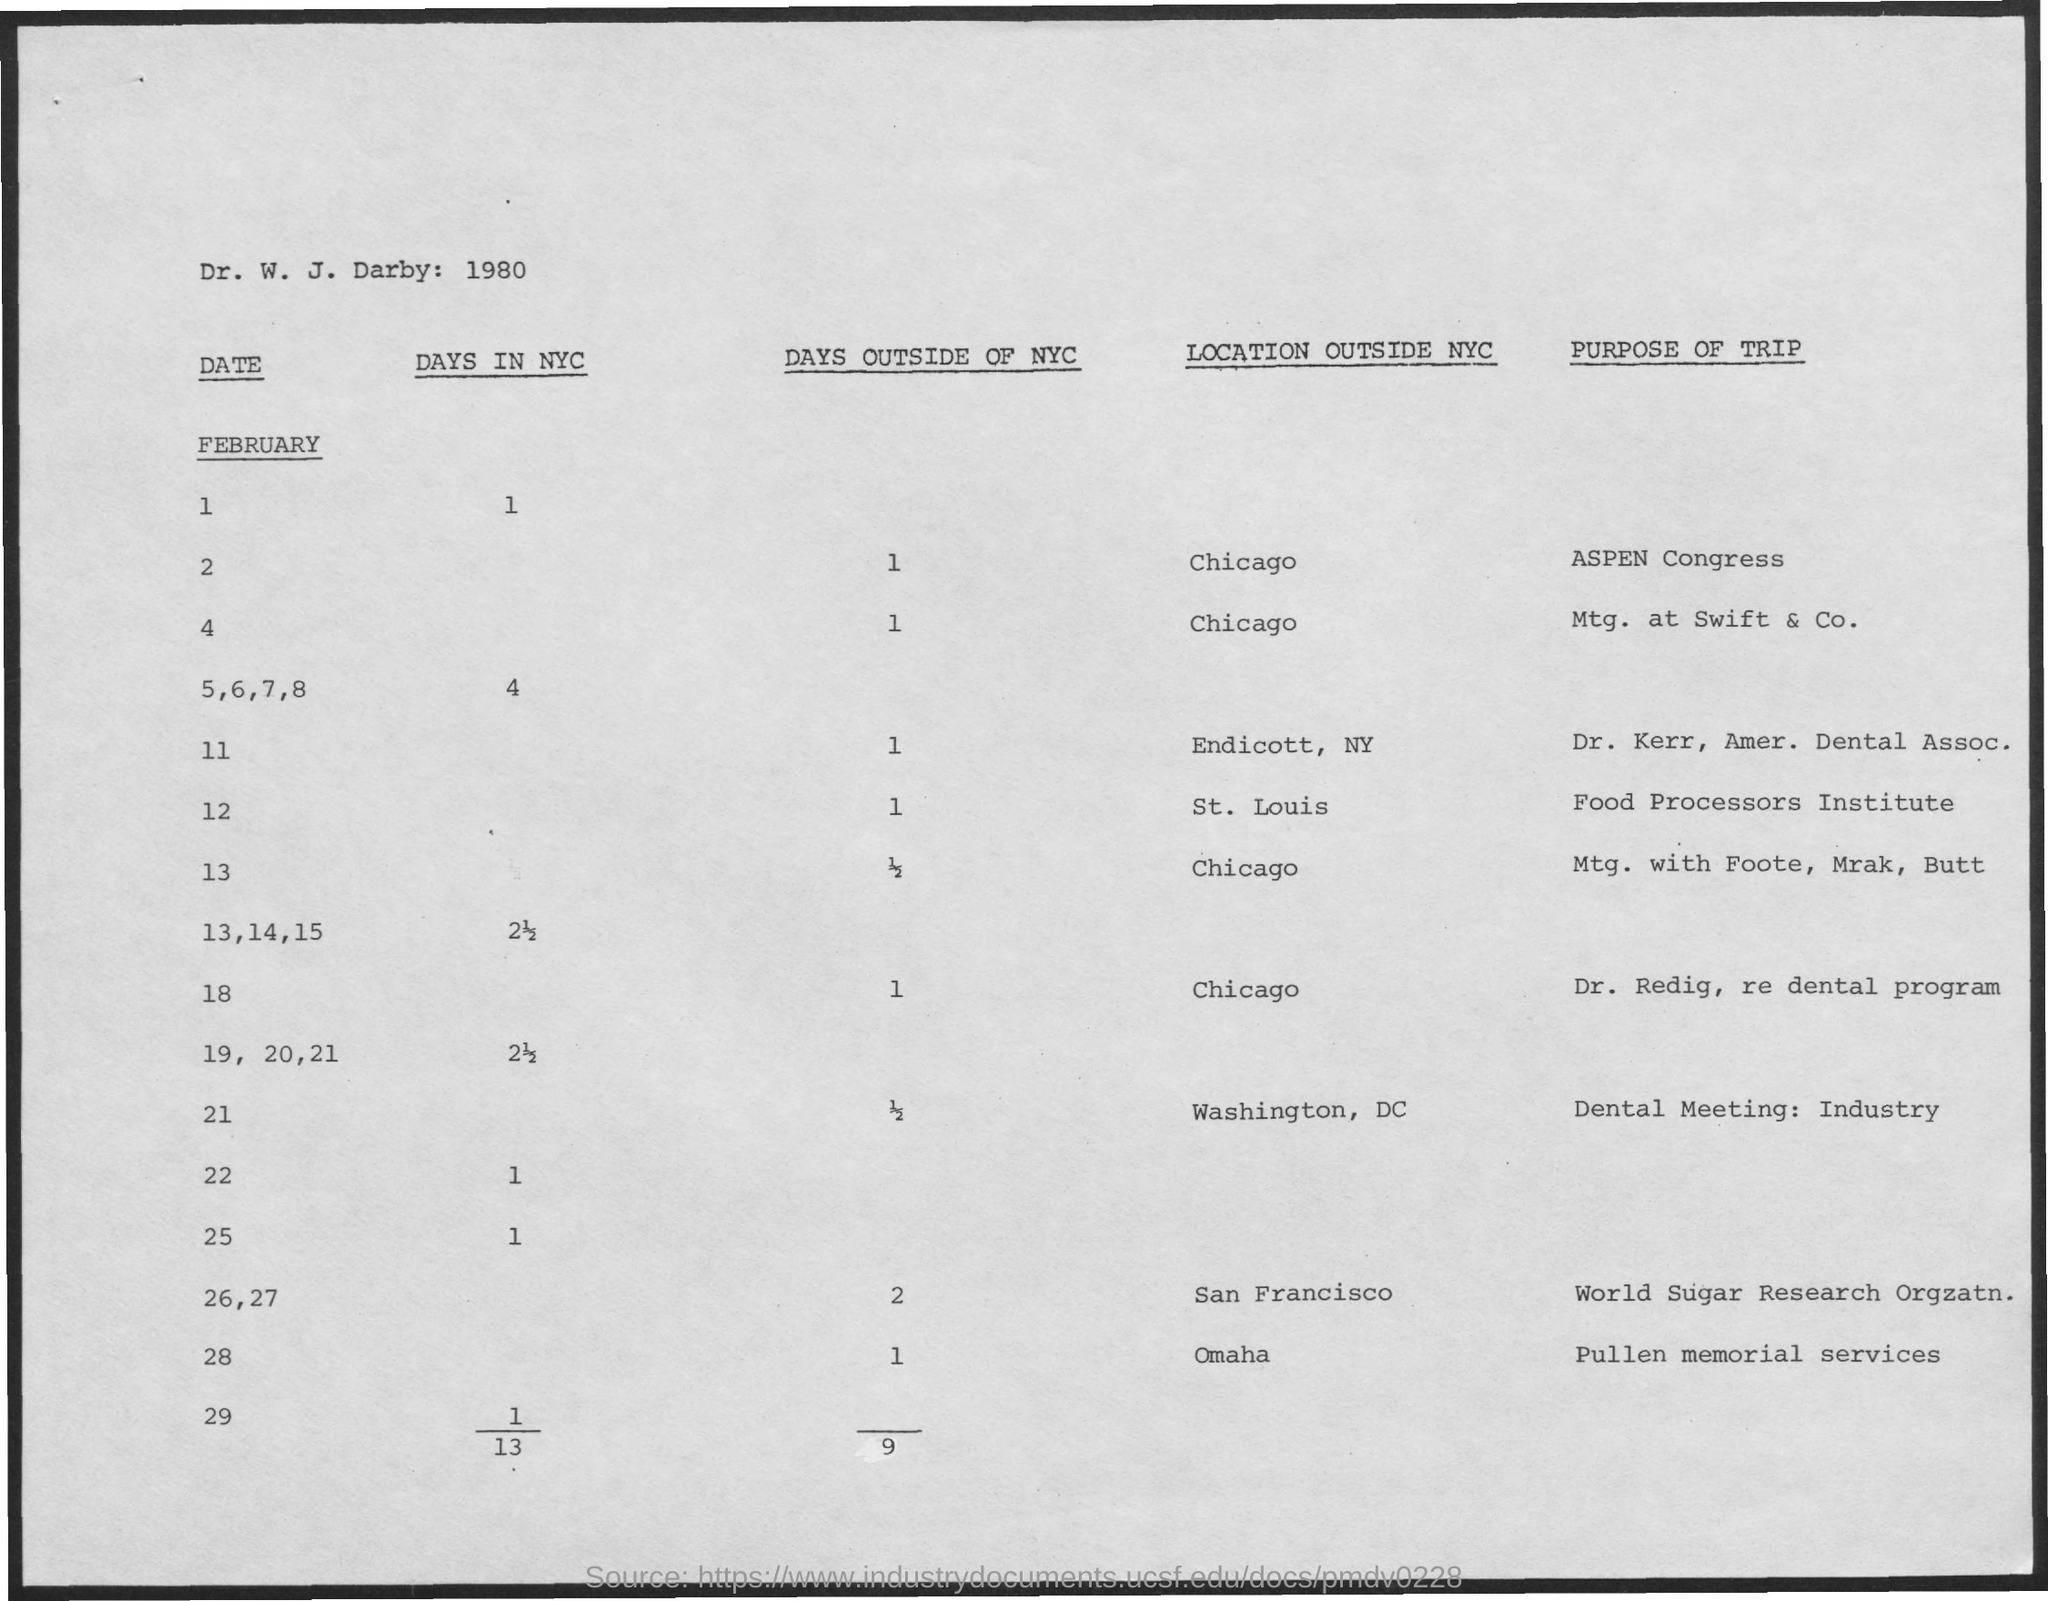What are the number of Days outside of NYC for February 2?
Your answer should be very brief. 1. What are the number of Days outside of NYC for February 4?
Provide a succinct answer. 1. What are the number of Days outside of NYC for February 11?
Your response must be concise. 1. What are the number of Days outside of NYC for February 12?
Offer a very short reply. 1. What are the number of Days outside of NYC for February 13?
Your answer should be compact. 1/2. What are the number of Days outside of NYC for February 18?
Keep it short and to the point. 1. What are the number of Days outside of NYC for February 21?
Give a very brief answer. 1/2. What are the number of Days outside of NYC for February 26,27?
Give a very brief answer. 2. What are the number of Days outside of NYC for February 28?
Your answer should be very brief. 1. What are the number of Days in NYC for Februaray 1?
Offer a terse response. 1. 